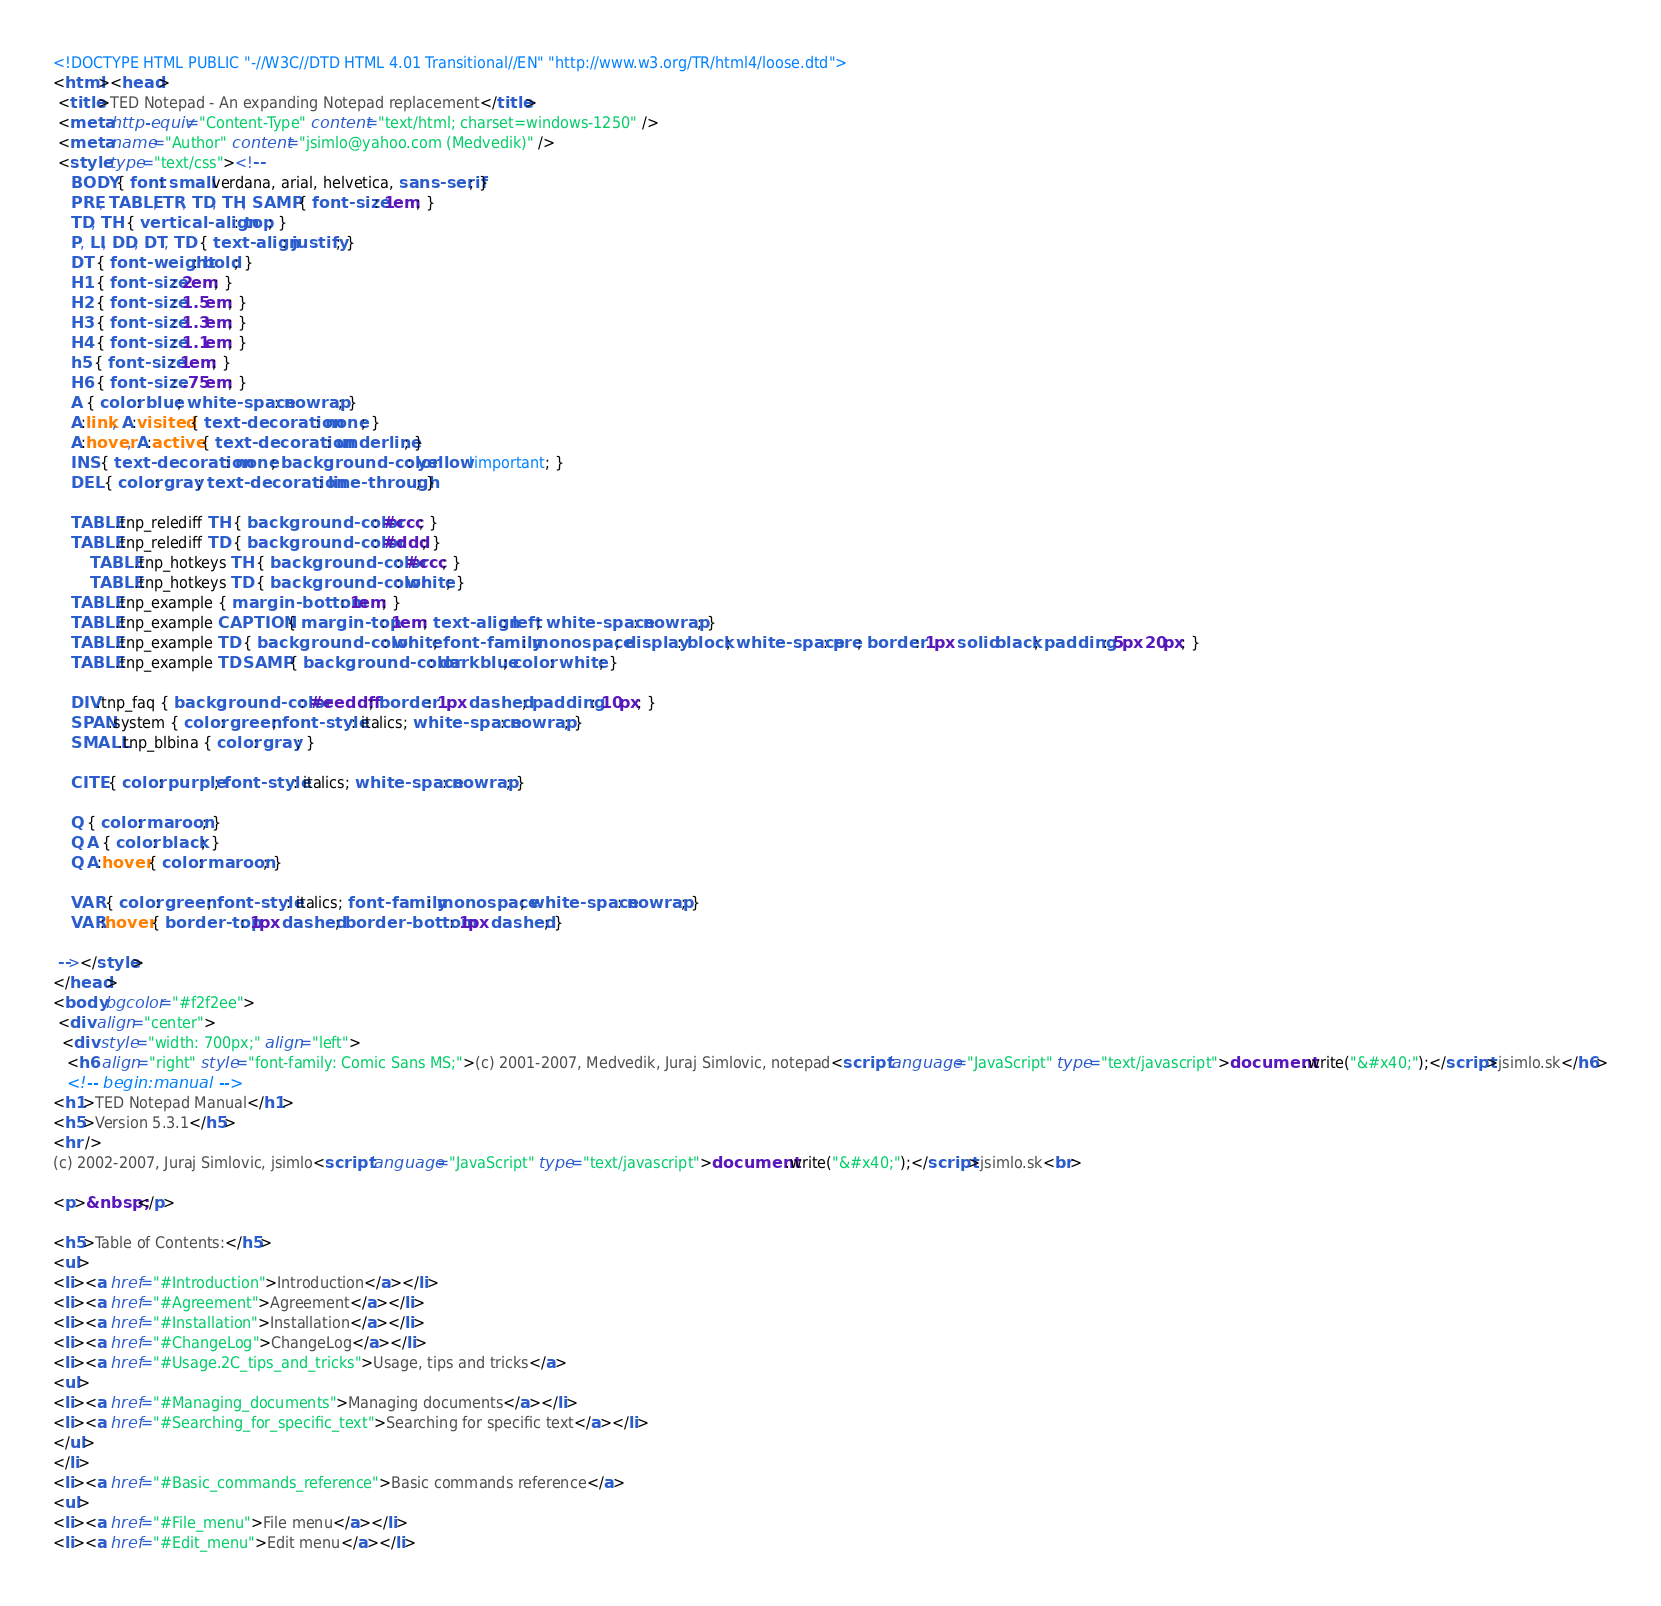<code> <loc_0><loc_0><loc_500><loc_500><_HTML_><!DOCTYPE HTML PUBLIC "-//W3C//DTD HTML 4.01 Transitional//EN" "http://www.w3.org/TR/html4/loose.dtd">
<html><head>
 <title>TED Notepad - An expanding Notepad replacement</title>
 <meta http-equiv="Content-Type" content="text/html; charset=windows-1250" />
 <meta name="Author" content="jsimlo@yahoo.com (Medvedik)" />
 <style type="text/css"><!--
	BODY { font: small verdana, arial, helvetica, sans-serif; }
	PRE, TABLE, TR, TD, TH, SAMP { font-size: 1em; }
	TD, TH { vertical-align: top; }
	P, LI, DD, DT, TD { text-align: justify; }
	DT { font-weight: bold; }
	H1 { font-size: 2em; }
	H2 { font-size: 1.5em; }
	H3 { font-size: 1.3em; }
	H4 { font-size: 1.1em; }
	h5 { font-size: 1em; }
	H6 { font-size: .75em; }
	A { color: blue; white-space: nowrap; }
	A:link, A:visited { text-decoration: none; }
	A:hover, A:active { text-decoration: underline; }
	INS { text-decoration: none; background-color: yellow !important; }
	DEL { color: gray; text-decoration: line-through; }

	TABLE.tnp_relediff TH { background-color: #ccc; }
	TABLE.tnp_relediff TD { background-color: #ddd; }
        TABLE.tnp_hotkeys TH { background-color: #ccc; }
        TABLE.tnp_hotkeys TD { background-color: white; }
	TABLE.tnp_example { margin-bottom: 1em; }
	TABLE.tnp_example CAPTION { margin-top: 1em; text-align: left; white-space: nowrap; }
	TABLE.tnp_example TD { background-color: white; font-family: monospace; display: block; white-space: pre; border: 1px solid black; padding: 5px 20px; }
	TABLE.tnp_example TD SAMP { background-color: darkblue; color: white; }

	DIV.tnp_faq { background-color: #eeddff; border: 1px dashed; padding: 10px; }
	SPAN.system { color: green; font-style: italics; white-space: nowrap; }
	SMALL.tnp_blbina { color: gray; }

	CITE { color: purple; font-style: italics; white-space: nowrap; }

	Q { color: maroon; }
	Q A { color: black; }
	Q A:hover { color: maroon; }

	VAR { color: green; font-style: italics; font-family: monospace; white-space: nowrap; } 
	VAR:hover { border-top: 1px dashed; border-bottom: 1px dashed; }

 --></style>
</head>
<body bgcolor="#f2f2ee">
 <div align="center">
  <div style="width: 700px;" align="left">
   <h6 align="right" style="font-family: Comic Sans MS;">(c) 2001-2007, Medvedik, Juraj Simlovic, notepad<script language="JavaScript" type="text/javascript">document.write("&#x40;");</script>jsimlo.sk</h6>
   <!-- begin:manual -->
<h1>TED Notepad Manual</h1>
<h5>Version 5.3.1</h5>
<hr />
(c) 2002-2007, Juraj Simlovic, jsimlo<script language="JavaScript" type="text/javascript">document.write("&#x40;");</script>jsimlo.sk<br>

<p>&nbsp;</p>

<h5>Table of Contents:</h5>
<ul>
<li><a href="#Introduction">Introduction</a></li>
<li><a href="#Agreement">Agreement</a></li>
<li><a href="#Installation">Installation</a></li>
<li><a href="#ChangeLog">ChangeLog</a></li>
<li><a href="#Usage.2C_tips_and_tricks">Usage, tips and tricks</a>
<ul>
<li><a href="#Managing_documents">Managing documents</a></li>
<li><a href="#Searching_for_specific_text">Searching for specific text</a></li>
</ul>
</li>
<li><a href="#Basic_commands_reference">Basic commands reference</a>
<ul>
<li><a href="#File_menu">File menu</a></li>
<li><a href="#Edit_menu">Edit menu</a></li></code> 